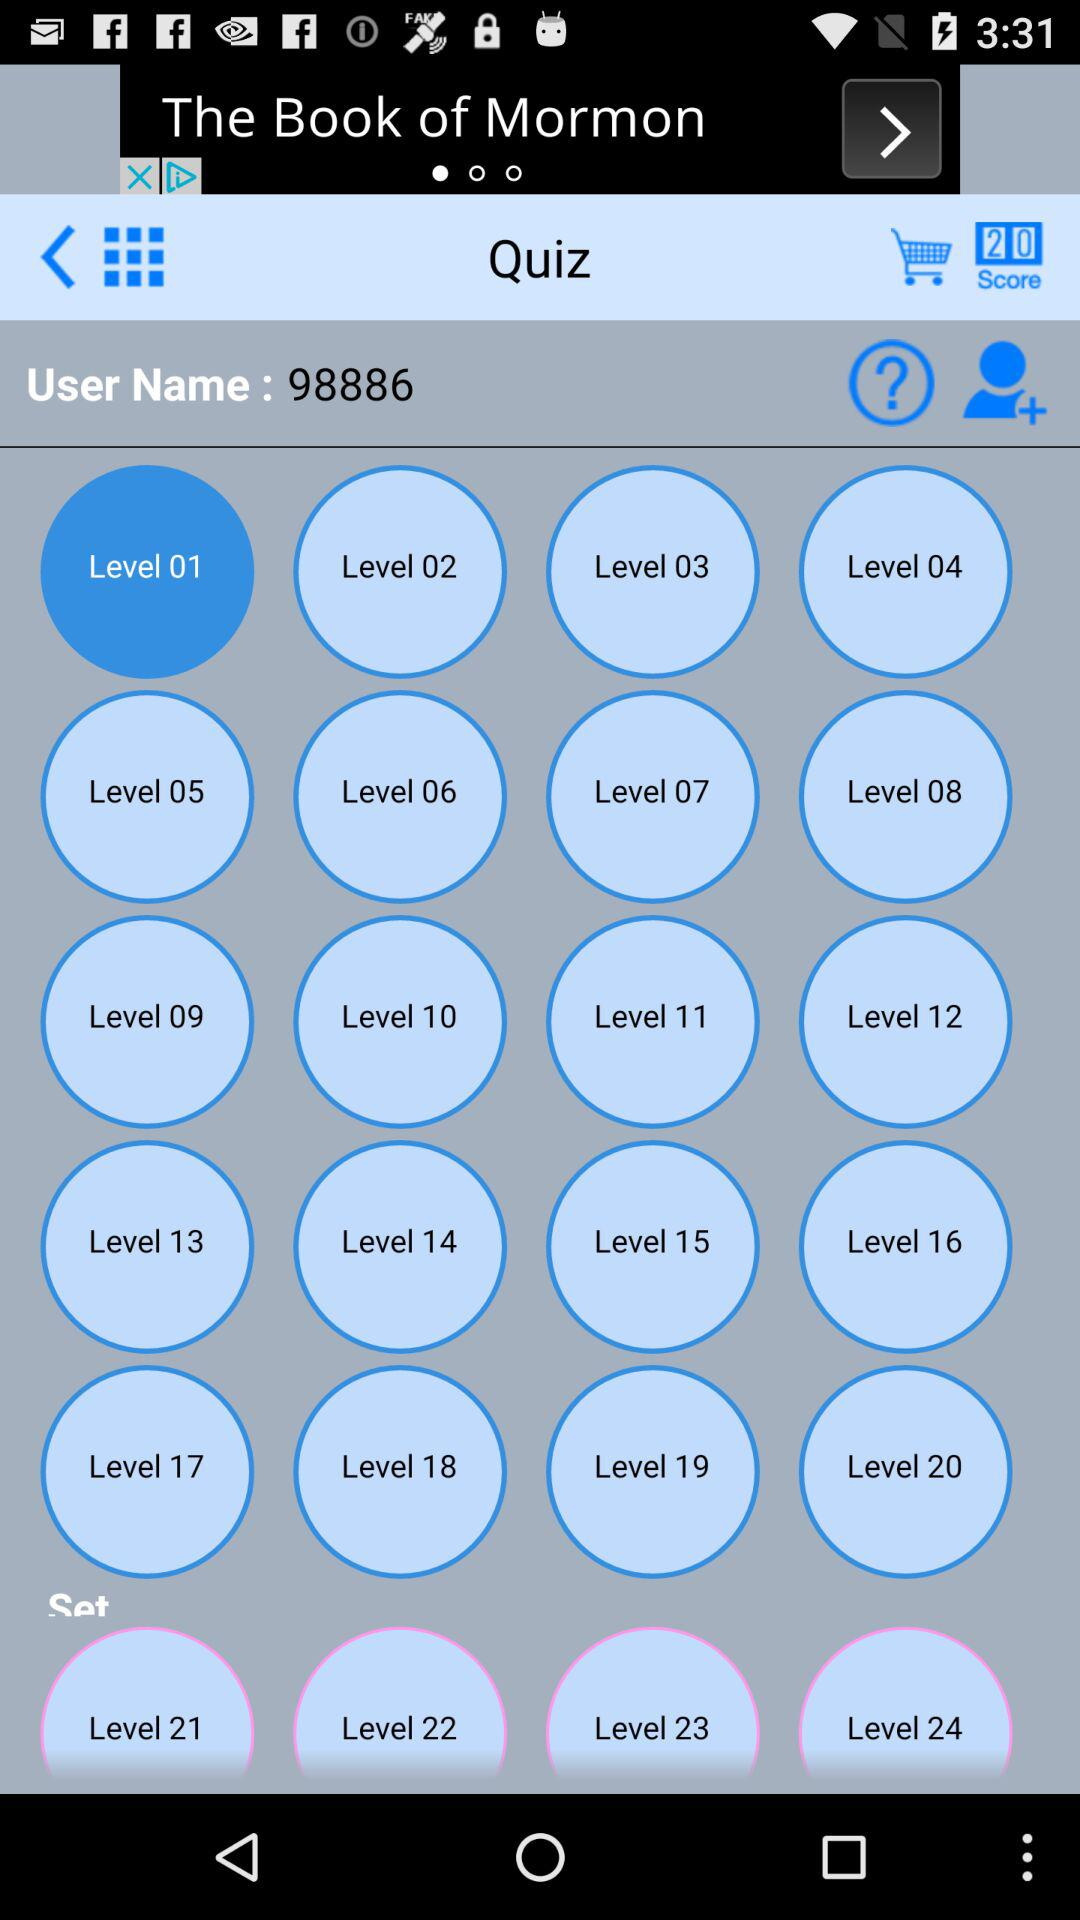At which level am I? You are at level 1. 